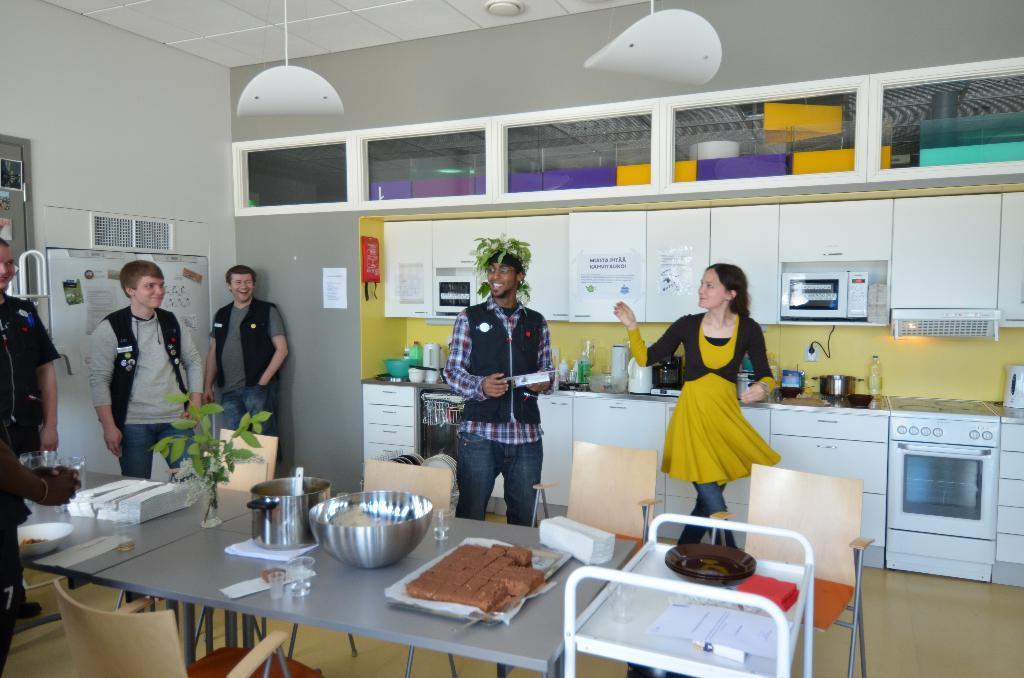Describe this image in one or two sentences. In this image we can see a group of persons are standing and smiling, and in front here is the table and vessels and food items and flower pot and some objects on it, and here is the table and papers on it, and here is the wall. 